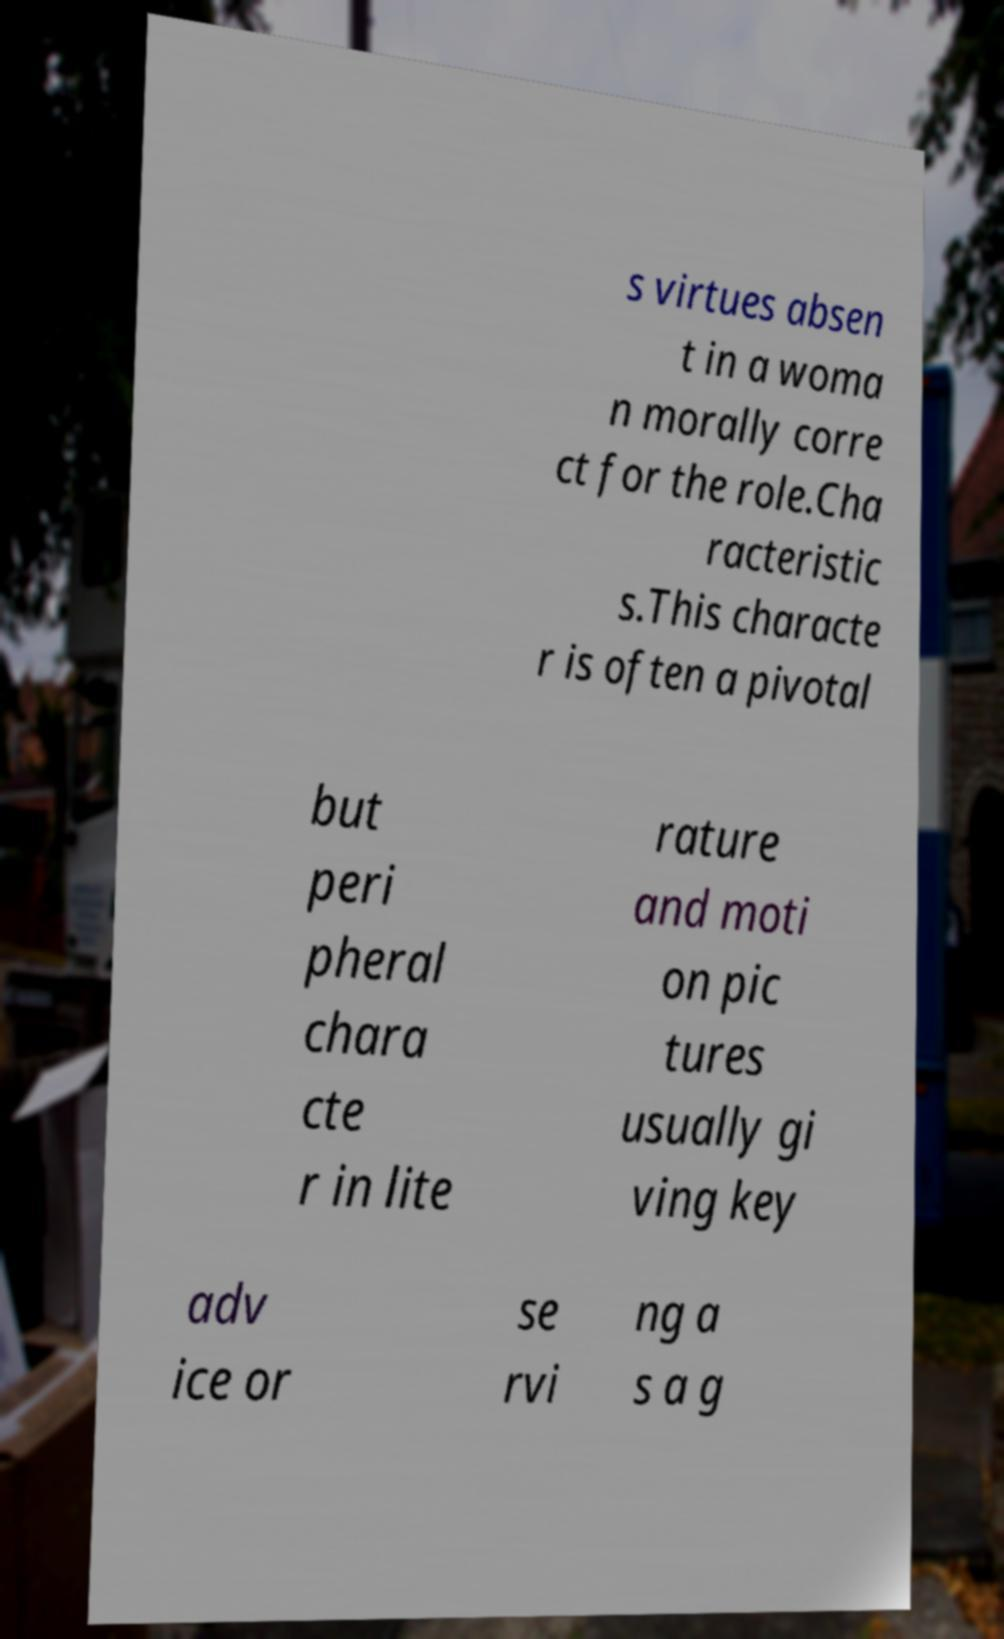What messages or text are displayed in this image? I need them in a readable, typed format. s virtues absen t in a woma n morally corre ct for the role.Cha racteristic s.This characte r is often a pivotal but peri pheral chara cte r in lite rature and moti on pic tures usually gi ving key adv ice or se rvi ng a s a g 